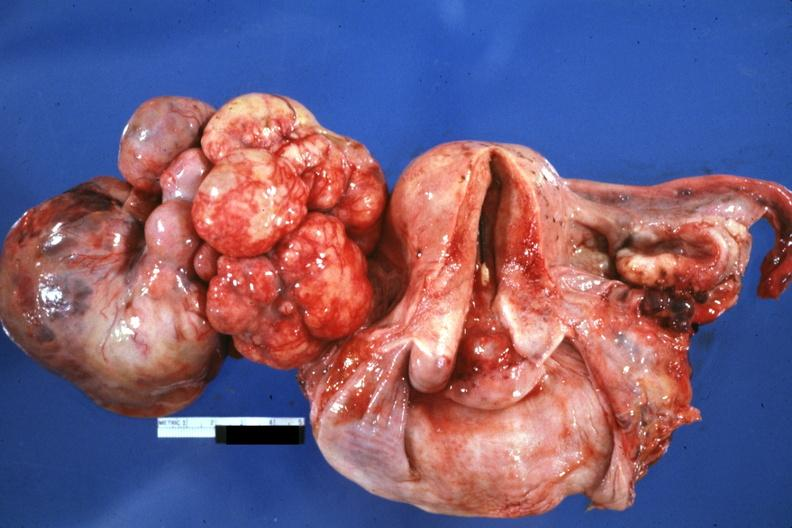what does this image show?
Answer the question using a single word or phrase. Large mass lobular tumor lung primary 